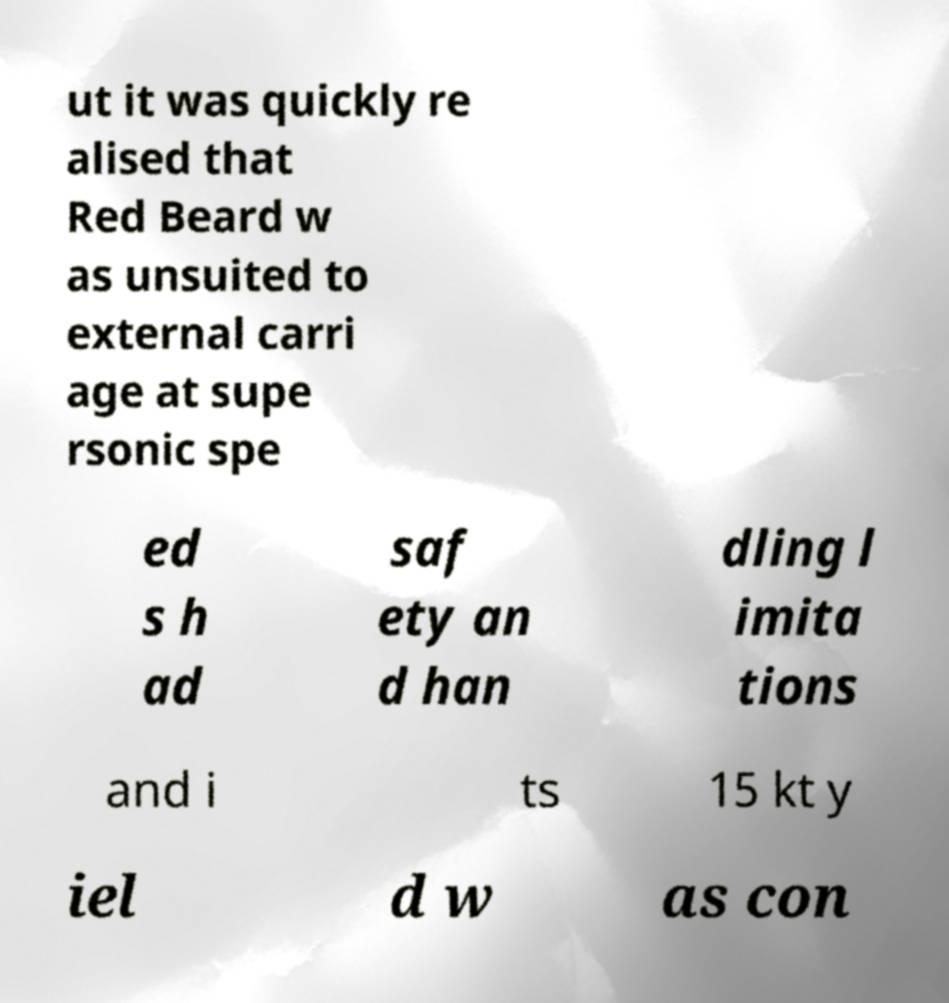I need the written content from this picture converted into text. Can you do that? ut it was quickly re alised that Red Beard w as unsuited to external carri age at supe rsonic spe ed s h ad saf ety an d han dling l imita tions and i ts 15 kt y iel d w as con 